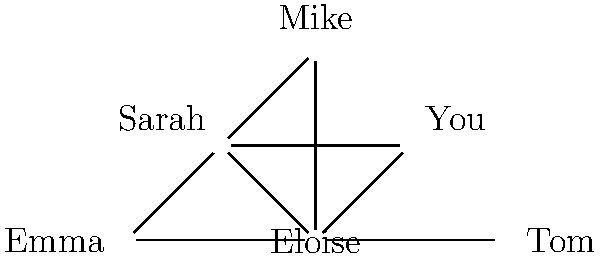In Eloise's social network diagram, who has the highest degree centrality (most direct connections)? To determine who has the highest degree centrality in Eloise's social network, we need to count the number of direct connections for each person:

1. Eloise: Connected to You, Sarah, Mike, Emma, and Tom (5 connections)
2. You: Connected to Eloise and Sarah (2 connections)
3. Sarah: Connected to Eloise, You, and Mike (3 connections)
4. Mike: Connected to Eloise, Sarah, and Emma (3 connections)
5. Emma: Connected to Eloise and Mike (2 connections)
6. Tom: Connected to Eloise (1 connection)

By comparing these numbers, we can see that Eloise has the highest number of direct connections (5), making her the person with the highest degree centrality in this social network.
Answer: Eloise 